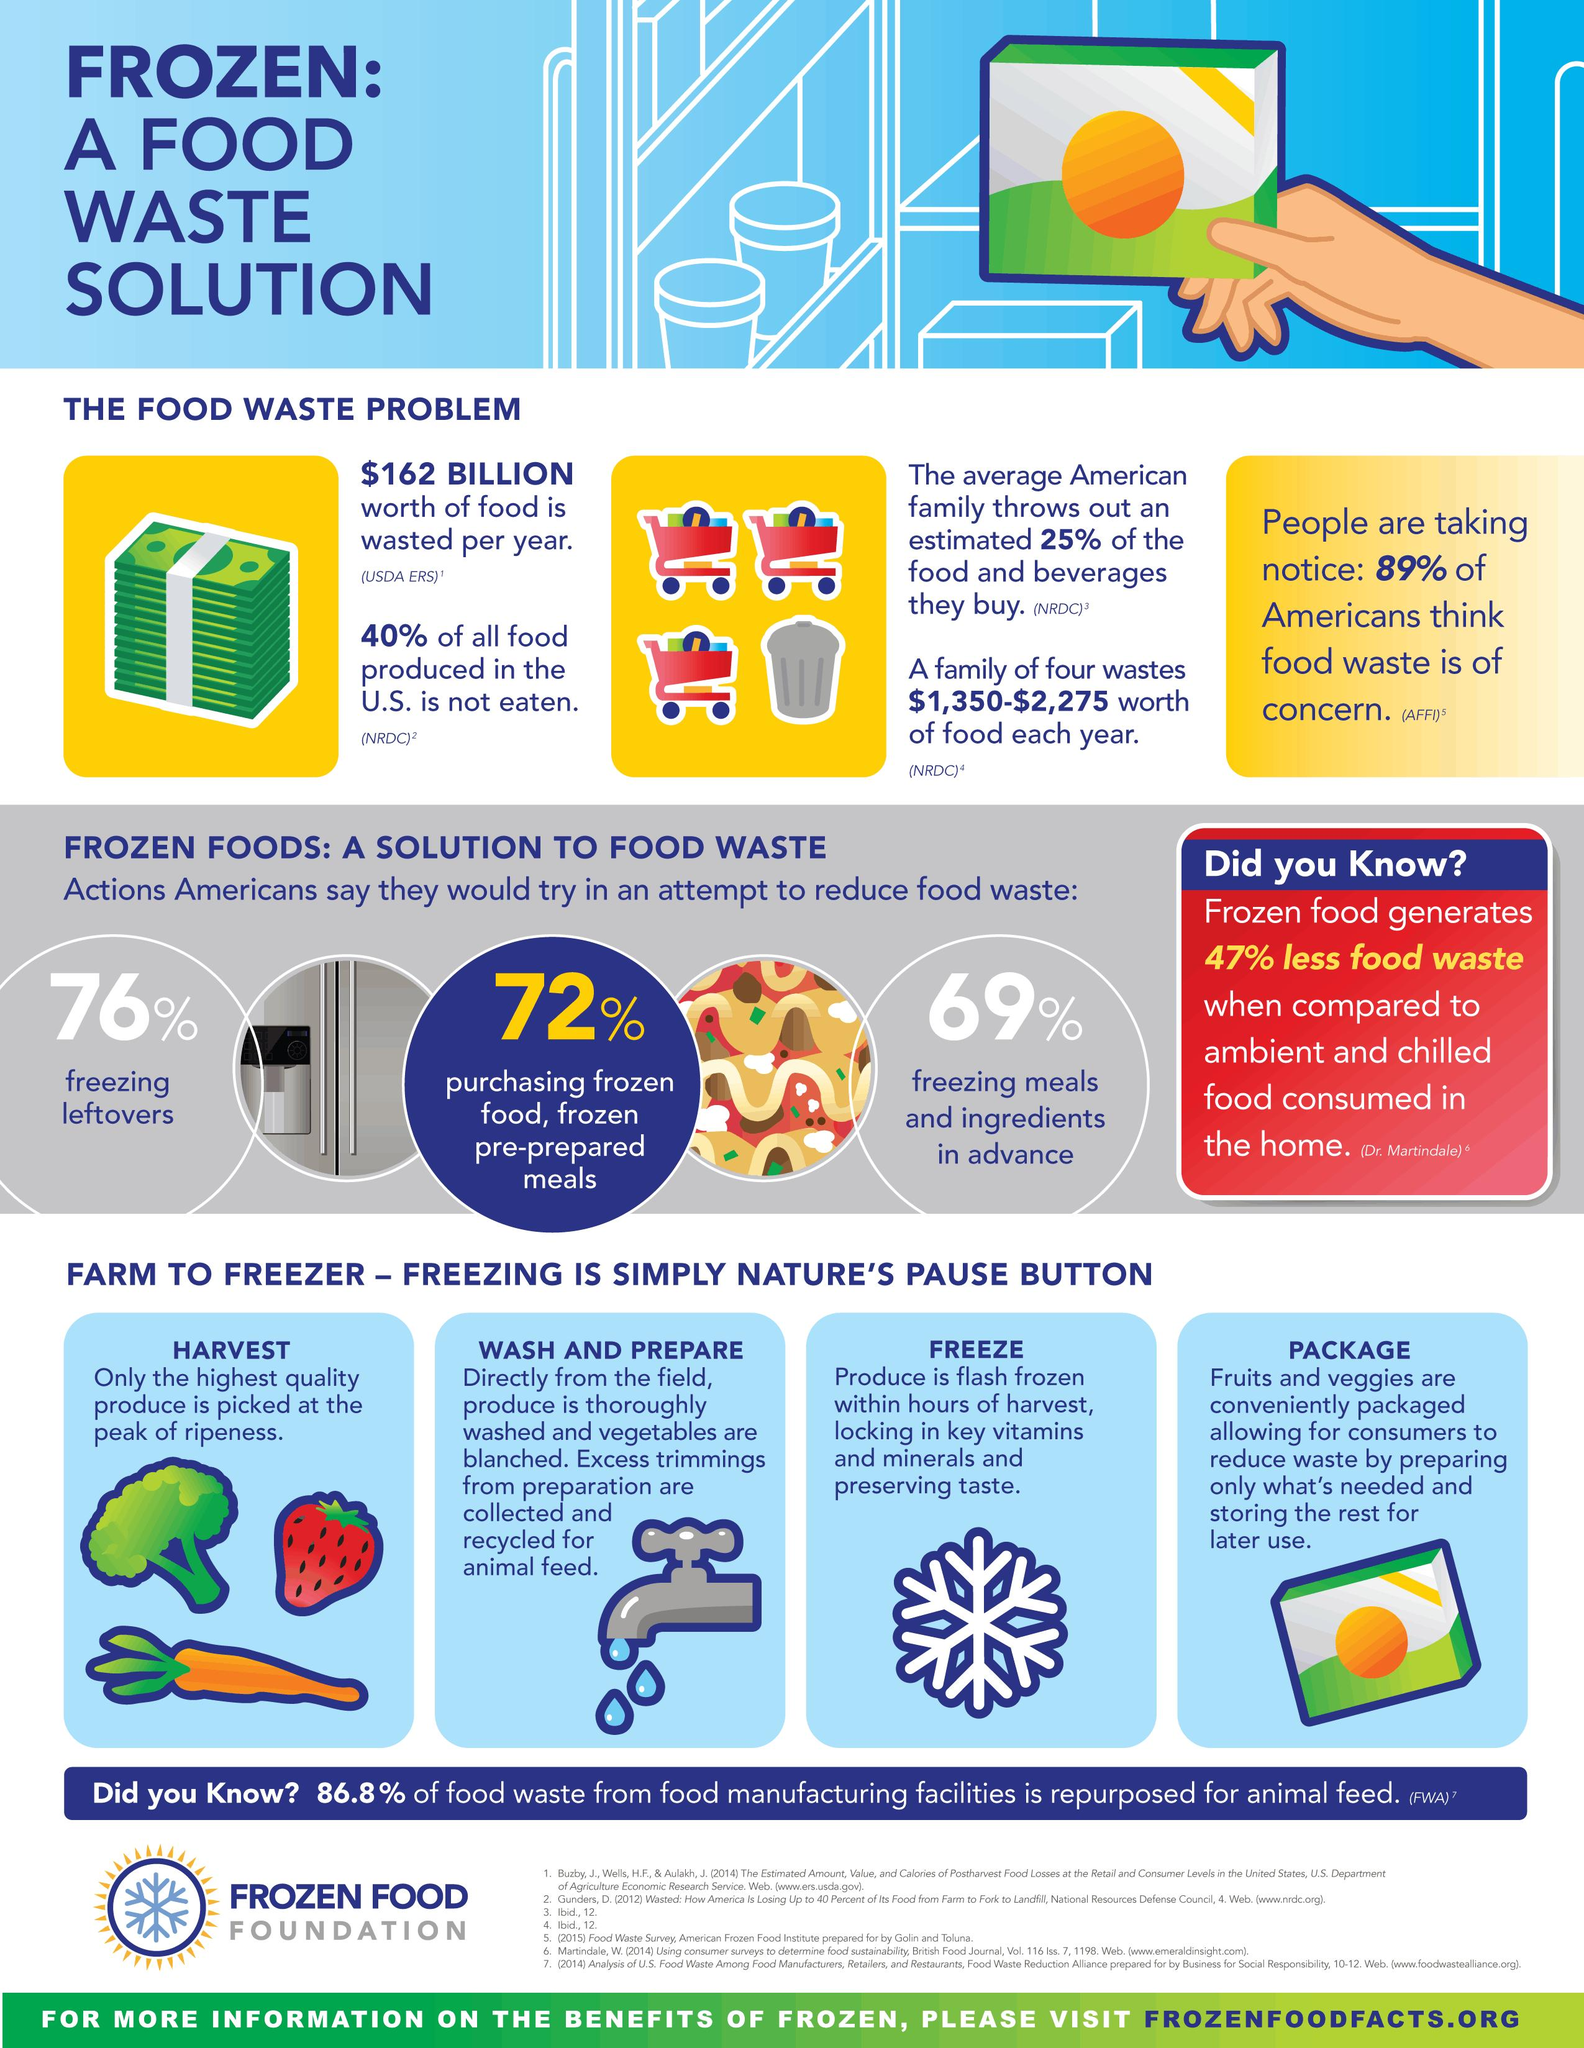Specify some key components in this picture. The procedure before washing and preparing in the process of food production typically involves harvesting the crops or gathering the ingredients. After the harvesting process in the food production procedure, the next step is to wash and prepare the food items for consumption. This involves removing any dirt, debris, or impurities from the produce to ensure they are clean and safe for consumption. A recent survey indicates that over 11% of American adults believe that food waste is not a significant concern. The process of food production before packaging involves several steps, including the harvesting of crops, their washing and preparation, and the freezing of perishable items. After harvesting, the process of food production involves several steps, including washing and preparing the produce, freezing it for future use, and packaging it for distribution. 